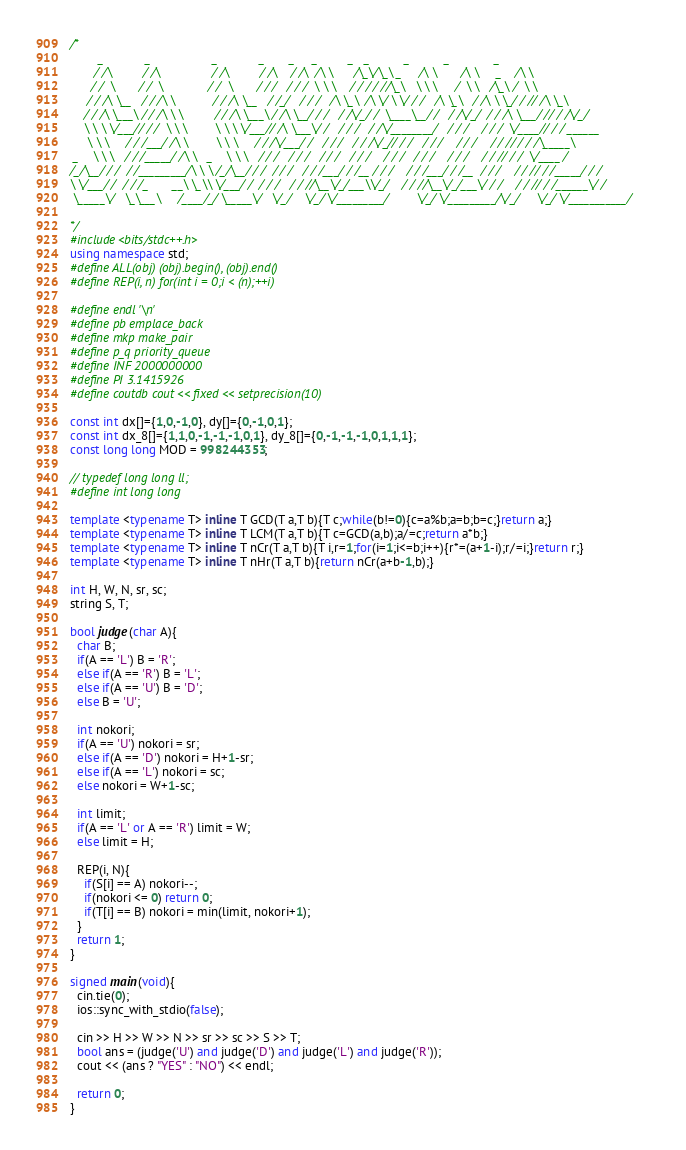<code> <loc_0><loc_0><loc_500><loc_500><_C++_>/*
        _            _                  _            _       _     _         _   _          _          _             _        
       / /\         / /\               / /\         / /\    / /\  /\ \      /\_\/\_\ _     /\ \       /\ \     _    /\ \      
      / /  \       / /  \             / /  \       / / /   / / /  \ \ \    / / / / //\_\   \ \ \     /  \ \   /\_\ /  \ \     
     / / /\ \__   / / /\ \           / / /\ \__   / /_/   / / /   /\ \_\  /\ \/ \ \/ / /   /\ \_\   / /\ \ \_/ / // /\ \_\    
    / / /\ \___\ / / /\ \ \         / / /\ \___\ / /\ \__/ / /   / /\/_/ /  \____\__/ /   / /\/_/  / / /\ \___/ // / /\/_/    
    \ \ \ \/___// / /  \ \ \        \ \ \ \/___// /\ \___\/ /   / / /   / /\/________/   / / /    / / /  \/____// / / ______  
     \ \ \     / / /___/ /\ \        \ \ \     / / /\/___/ /   / / /   / / /\/_// / /   / / /    / / /    / / // / / /\_____\ 
 _    \ \ \   / / /_____/ /\ \   _    \ \ \   / / /   / / /   / / /   / / /    / / /   / / /    / / /    / / // / /  \/____ / 
/_/\__/ / /  / /_________/\ \ \ /_/\__/ / /  / / /   / / /___/ / /__ / / /    / / /___/ / /__  / / /    / / // / /_____/ / /  
\ \/___/ /  / / /_       __\ \_\\ \/___/ /  / / /   / / //\__\/_/___\\/_/    / / //\__\/_/___\/ / /    / / // / /______\/ /   
 \_____\/   \_\___\     /____/_/ \_____\/   \/_/    \/_/ \/_________/        \/_/ \/_________/\/_/     \/_/ \/___________/    
                                                                                                                              
*/
#include<bits/stdc++.h>
using namespace std;
#define ALL(obj) (obj).begin(), (obj).end()
#define REP(i, n) for(int i = 0;i < (n);++i)

#define endl '\n'
#define pb emplace_back
#define mkp make_pair
#define p_q priority_queue
#define INF 2000000000
#define PI 3.1415926
#define coutdb cout << fixed << setprecision(10)

const int dx[]={1,0,-1,0}, dy[]={0,-1,0,1};
const int dx_8[]={1,1,0,-1,-1,-1,0,1}, dy_8[]={0,-1,-1,-1,0,1,1,1};
const long long MOD = 998244353;

// typedef long long ll;
#define int long long

template <typename T> inline T GCD(T a,T b){T c;while(b!=0){c=a%b;a=b;b=c;}return a;}
template <typename T> inline T LCM(T a,T b){T c=GCD(a,b);a/=c;return a*b;}
template <typename T> inline T nCr(T a,T b){T i,r=1;for(i=1;i<=b;i++){r*=(a+1-i);r/=i;}return r;}
template <typename T> inline T nHr(T a,T b){return nCr(a+b-1,b);}

int H, W, N, sr, sc;
string S, T;

bool judge(char A){
  char B;
  if(A == 'L') B = 'R';
  else if(A == 'R') B = 'L';
  else if(A == 'U') B = 'D';
  else B = 'U';

  int nokori;
  if(A == 'U') nokori = sr;
  else if(A == 'D') nokori = H+1-sr;
  else if(A == 'L') nokori = sc;
  else nokori = W+1-sc;

  int limit;
  if(A == 'L' or A == 'R') limit = W;
  else limit = H;

  REP(i, N){
    if(S[i] == A) nokori--;
    if(nokori <= 0) return 0;
    if(T[i] == B) nokori = min(limit, nokori+1);
  }
  return 1;
}

signed main(void){
  cin.tie(0);
  ios::sync_with_stdio(false);

  cin >> H >> W >> N >> sr >> sc >> S >> T;
  bool ans = (judge('U') and judge('D') and judge('L') and judge('R'));
  cout << (ans ? "YES" : "NO") << endl;

  return 0;
}</code> 